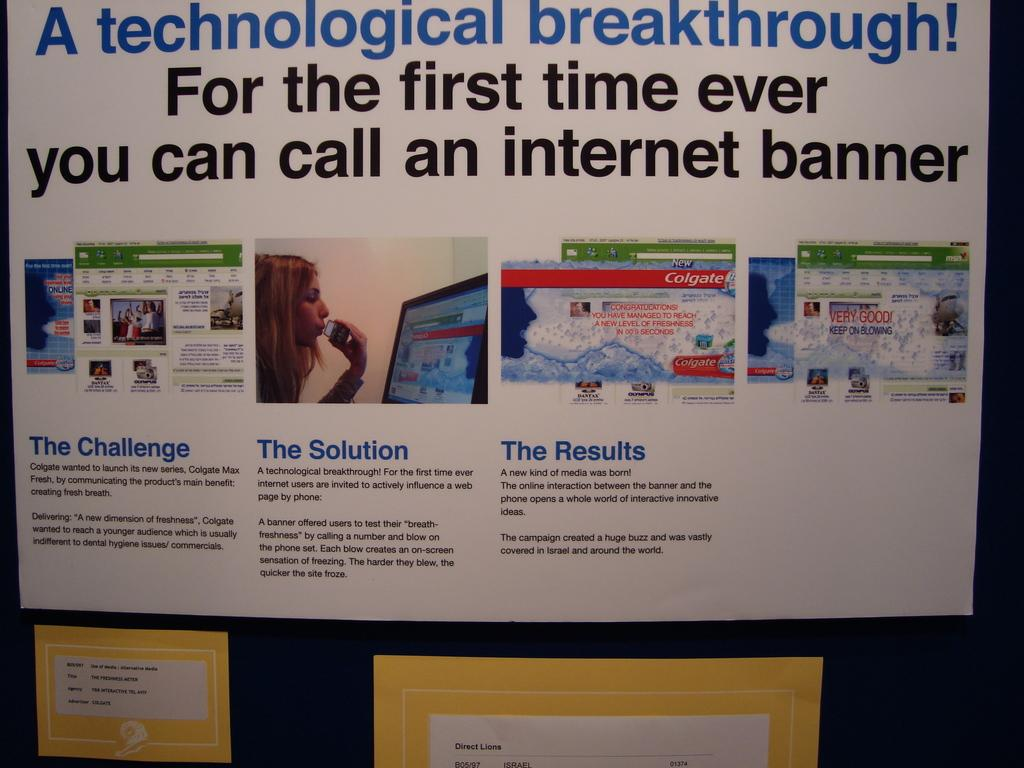<image>
Render a clear and concise summary of the photo. A poster titled A technological breakthrough! For the first time ever you can call and Internet banner. 